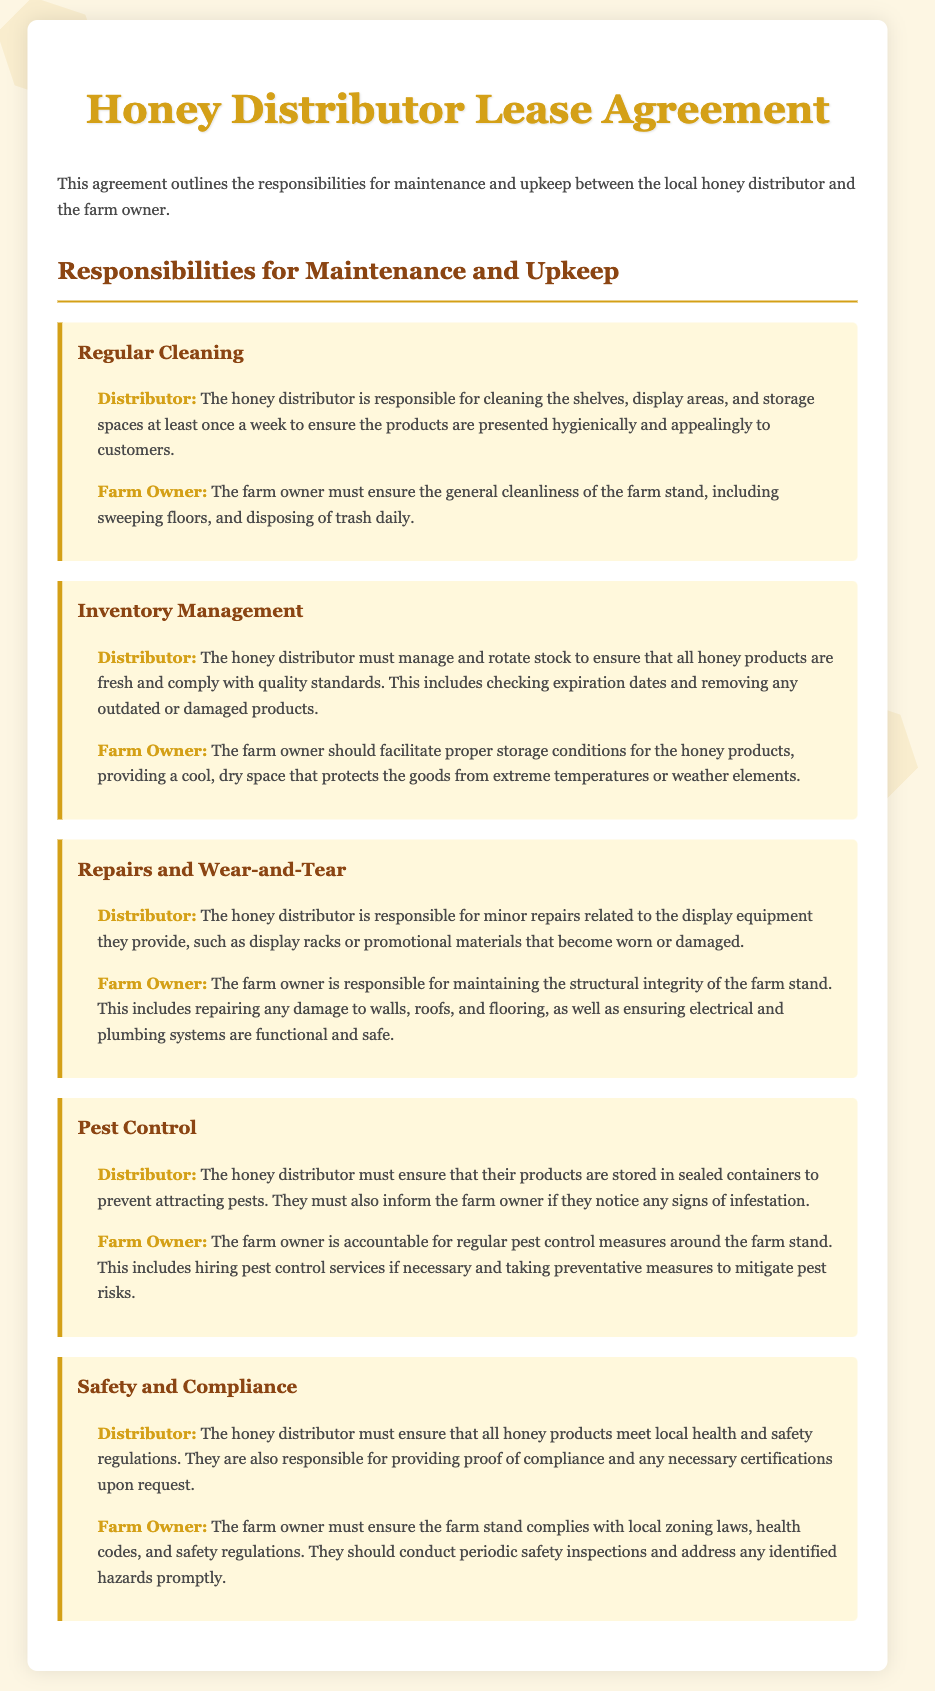What is the distributor responsible for regarding cleaning? The distributor is responsible for cleaning the shelves, display areas, and storage spaces at least once a week.
Answer: Cleaning shelves, display areas, and storage spaces What must the farm owner ensure daily? The farm owner must ensure the general cleanliness of the farm stand, including sweeping floors and disposing of trash.
Answer: General cleanliness, sweeping floors, disposing of trash Who manages stock and checks expiration dates? The honey distributor must manage and rotate stock to ensure that all honey products are fresh and comply with quality standards.
Answer: Honey distributor What are minor repairs related to? The honey distributor is responsible for minor repairs related to the display equipment they provide.
Answer: Display equipment Who is responsible for the structural integrity of the farm stand? The farm owner is responsible for maintaining the structural integrity of the farm stand.
Answer: Farm owner What should the distributor inform the farm owner about? The distributor must inform the farm owner if they notice any signs of infestation.
Answer: Signs of infestation What type of certifications must the distributor provide? The distributor is responsible for providing proof of compliance and any necessary certifications upon request.
Answer: Proof of compliance and necessary certifications What does the farm owner need to conduct periodically? The farm owner should conduct periodic safety inspections to ensure compliance.
Answer: Periodic safety inspections 